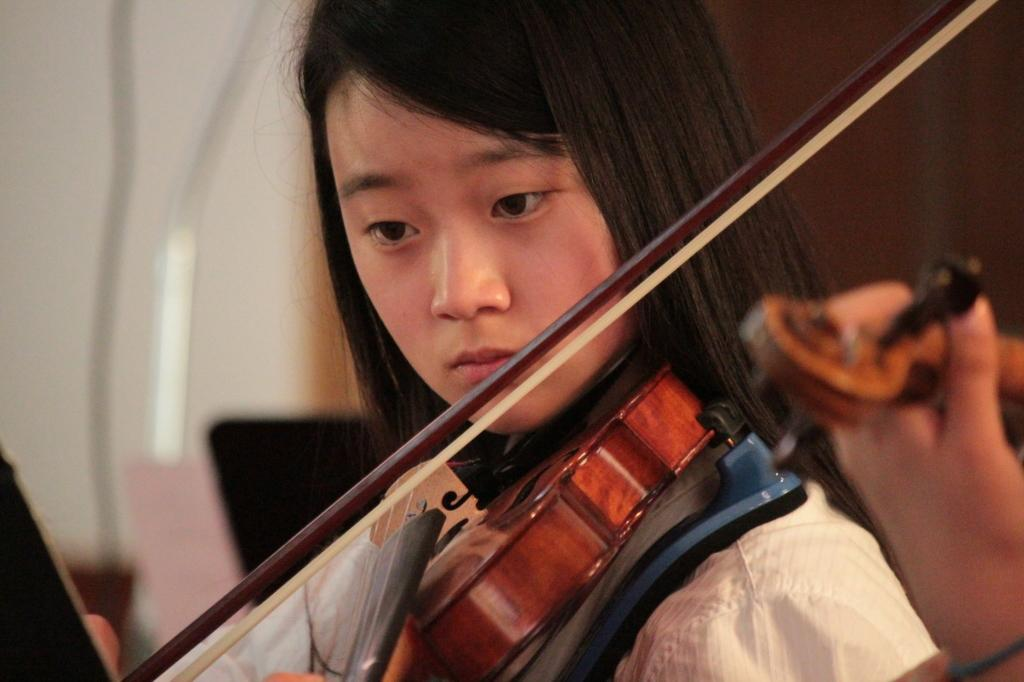What is the main subject of the image? The main subject of the image is a girl. What is the girl doing in the image? The girl is playing a violin. What decision did the girl make regarding the news about houses in the image? There is no reference to a decision, news, or houses in the image, so it's not possible to answer that question. 